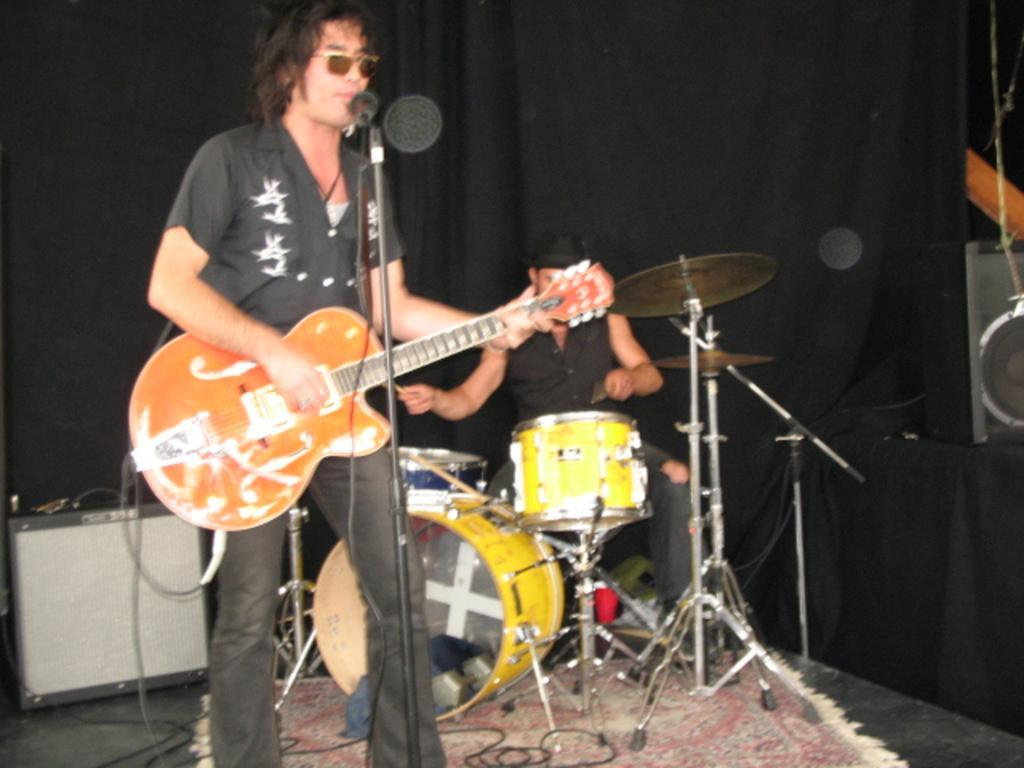How would you summarize this image in a sentence or two? This picture shows a man standing on the carpet, on the floor, holding a guitar and playing it. He is wearing spectacles. There is a microphone in front of him. In the background there is another guy playing drums and black curtain here. 